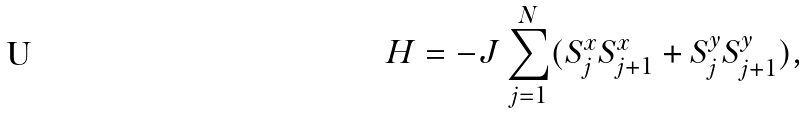Convert formula to latex. <formula><loc_0><loc_0><loc_500><loc_500>H = - J \sum _ { j = 1 } ^ { N } ( S _ { j } ^ { x } S _ { j + 1 } ^ { x } + S _ { j } ^ { y } S _ { j + 1 } ^ { y } ) ,</formula> 